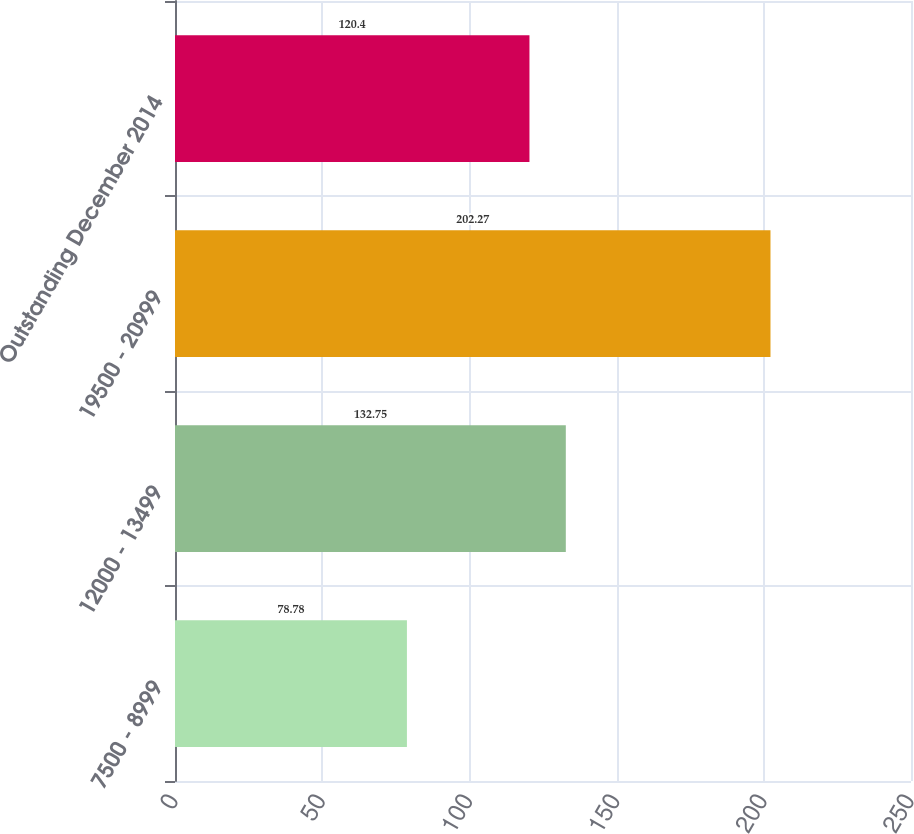<chart> <loc_0><loc_0><loc_500><loc_500><bar_chart><fcel>7500 - 8999<fcel>12000 - 13499<fcel>19500 - 20999<fcel>Outstanding December 2014<nl><fcel>78.78<fcel>132.75<fcel>202.27<fcel>120.4<nl></chart> 